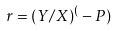Convert formula to latex. <formula><loc_0><loc_0><loc_500><loc_500>r = ( Y / X ) ^ { ( } - P )</formula> 